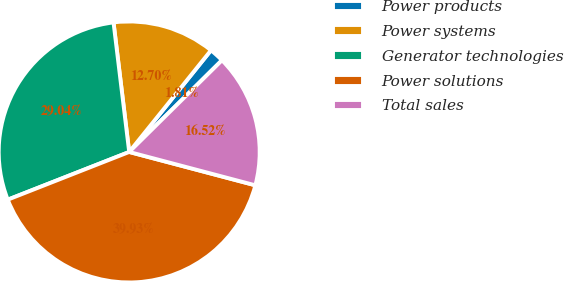Convert chart to OTSL. <chart><loc_0><loc_0><loc_500><loc_500><pie_chart><fcel>Power products<fcel>Power systems<fcel>Generator technologies<fcel>Power solutions<fcel>Total sales<nl><fcel>1.81%<fcel>12.7%<fcel>29.04%<fcel>39.93%<fcel>16.52%<nl></chart> 